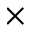<formula> <loc_0><loc_0><loc_500><loc_500>\times</formula> 